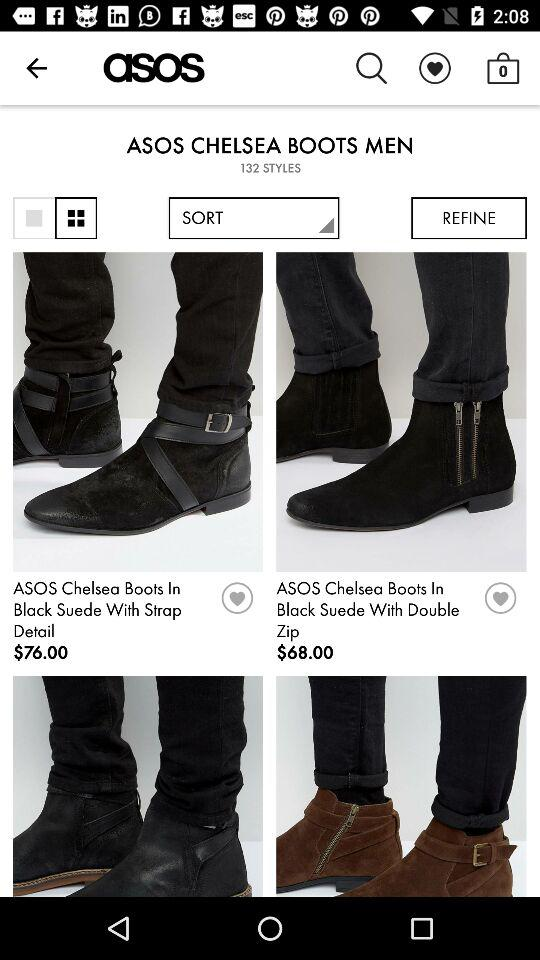What is the application name? The application name is "asos". 